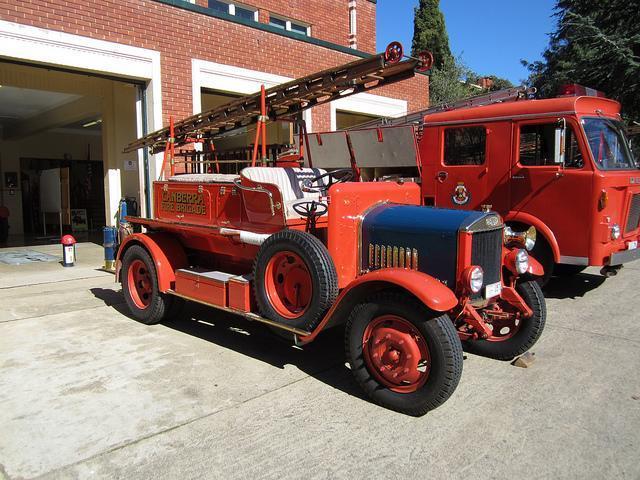How many wheels does the vehicle have on the ground?
Give a very brief answer. 4. How many trucks are there?
Give a very brief answer. 2. How many of the men are wearing a black shirt?
Give a very brief answer. 0. 